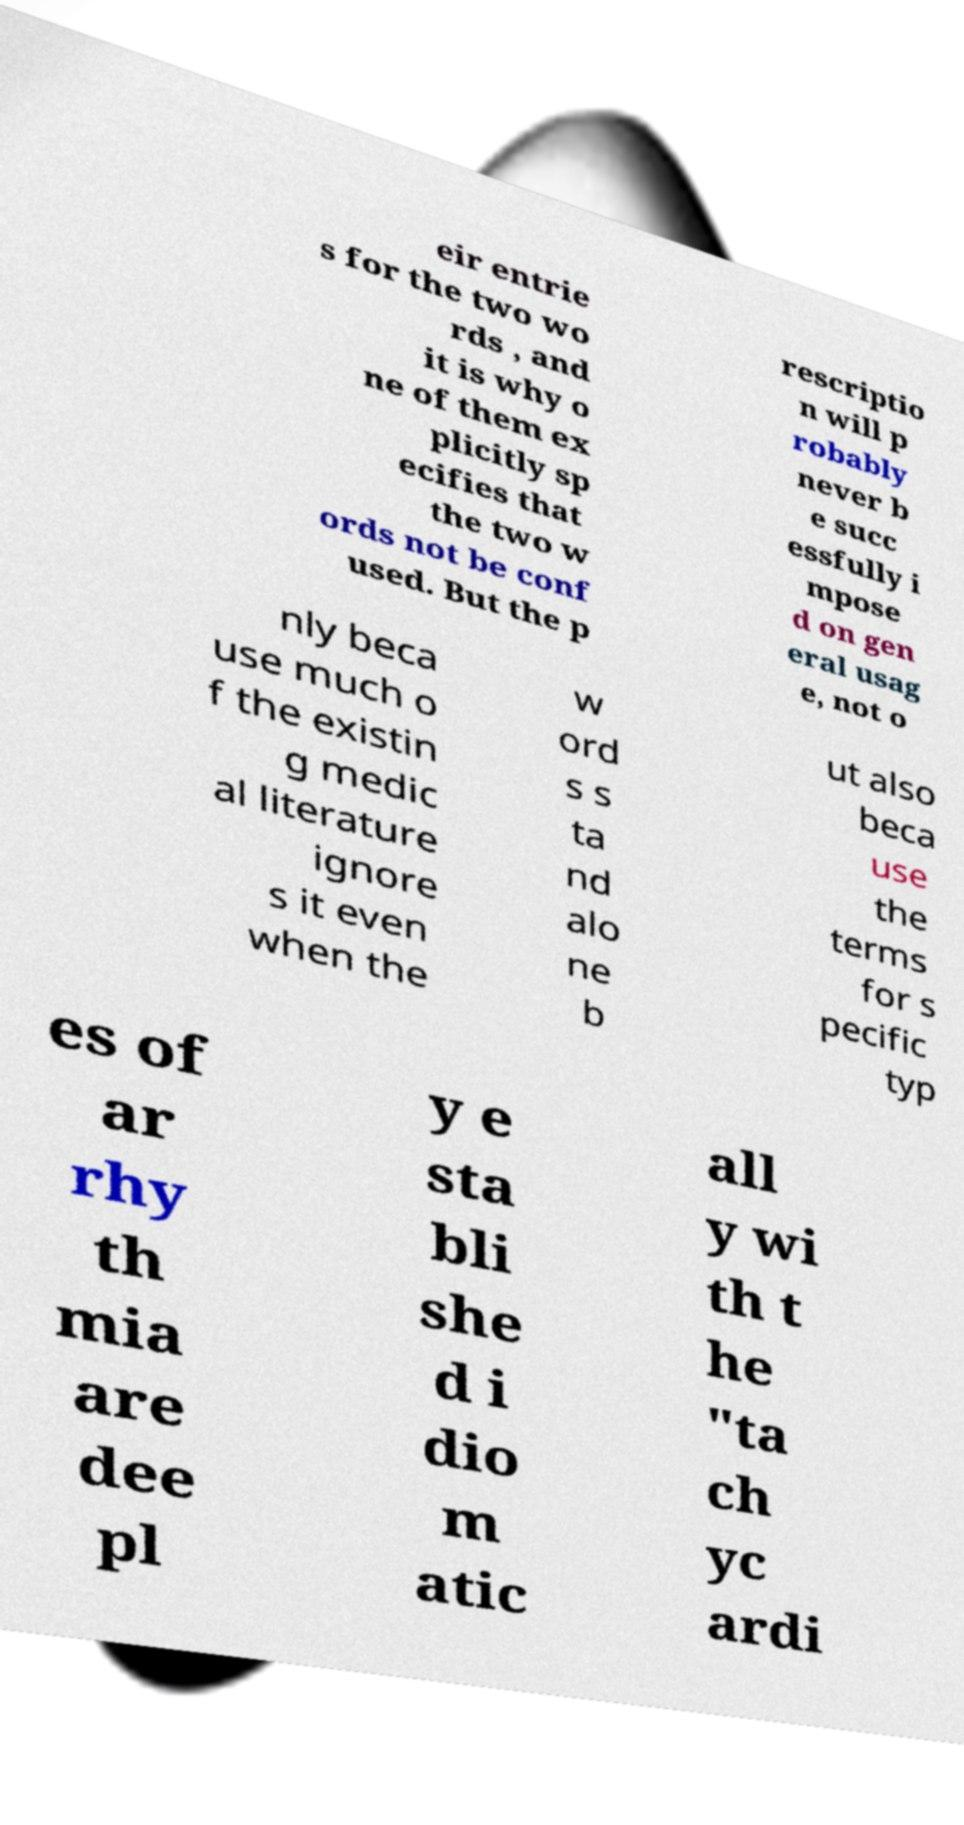There's text embedded in this image that I need extracted. Can you transcribe it verbatim? eir entrie s for the two wo rds , and it is why o ne of them ex plicitly sp ecifies that the two w ords not be conf used. But the p rescriptio n will p robably never b e succ essfully i mpose d on gen eral usag e, not o nly beca use much o f the existin g medic al literature ignore s it even when the w ord s s ta nd alo ne b ut also beca use the terms for s pecific typ es of ar rhy th mia are dee pl y e sta bli she d i dio m atic all y wi th t he "ta ch yc ardi 